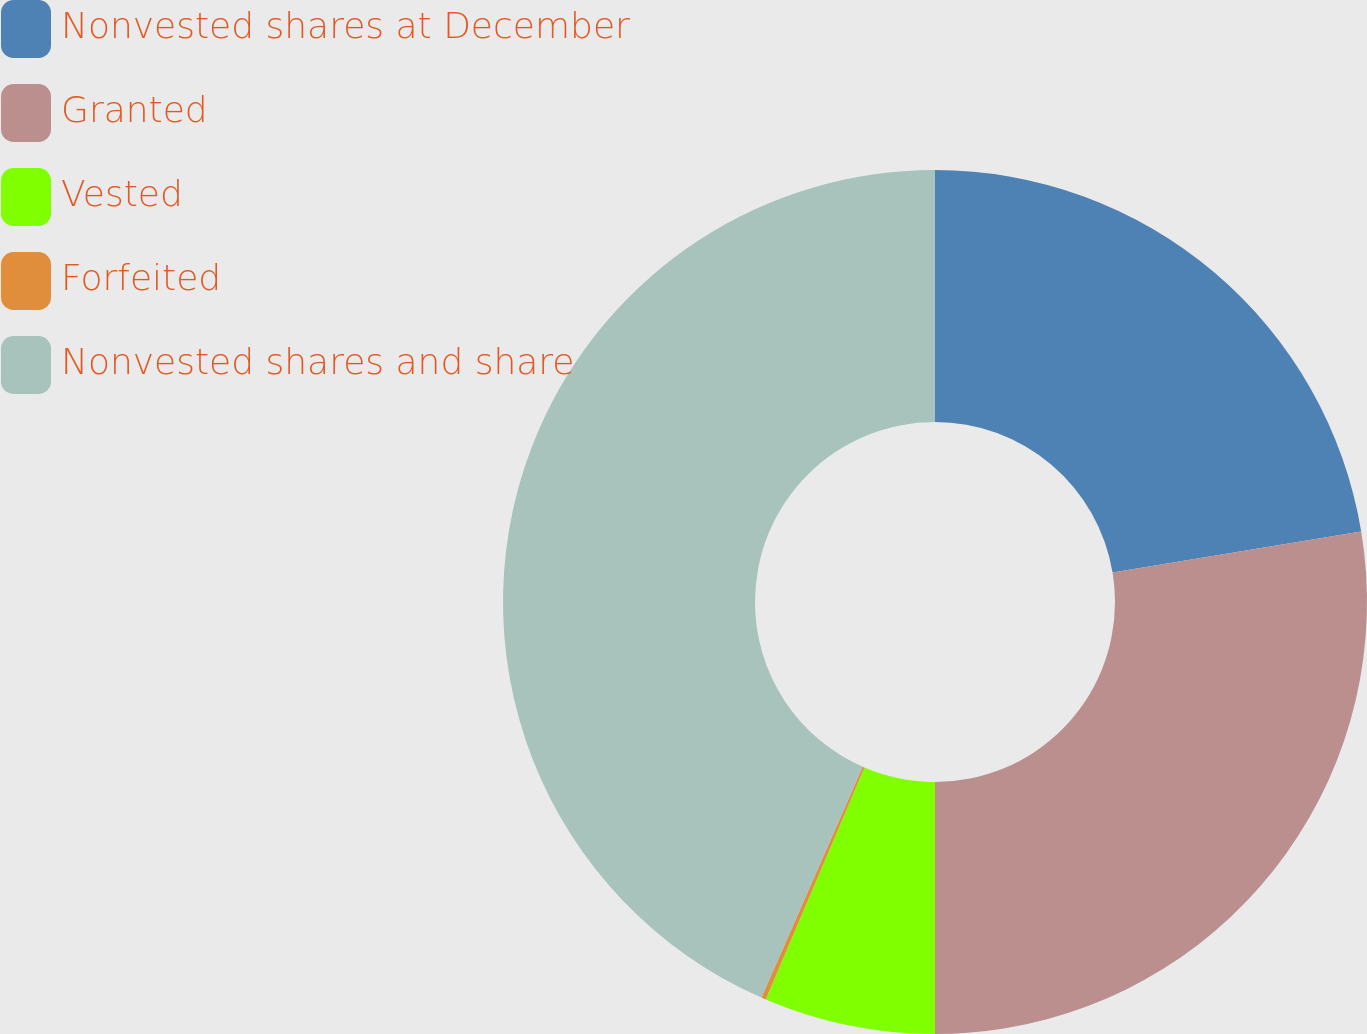Convert chart. <chart><loc_0><loc_0><loc_500><loc_500><pie_chart><fcel>Nonvested shares at December<fcel>Granted<fcel>Vested<fcel>Forfeited<fcel>Nonvested shares and share<nl><fcel>22.39%<fcel>27.61%<fcel>6.41%<fcel>0.17%<fcel>43.42%<nl></chart> 